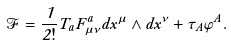Convert formula to latex. <formula><loc_0><loc_0><loc_500><loc_500>\mathcal { F } = \frac { 1 } { 2 ! } T _ { a } F ^ { a } _ { \mu \nu } d x ^ { \mu } \wedge d x ^ { \nu } + \tau _ { A } \varphi ^ { A } .</formula> 